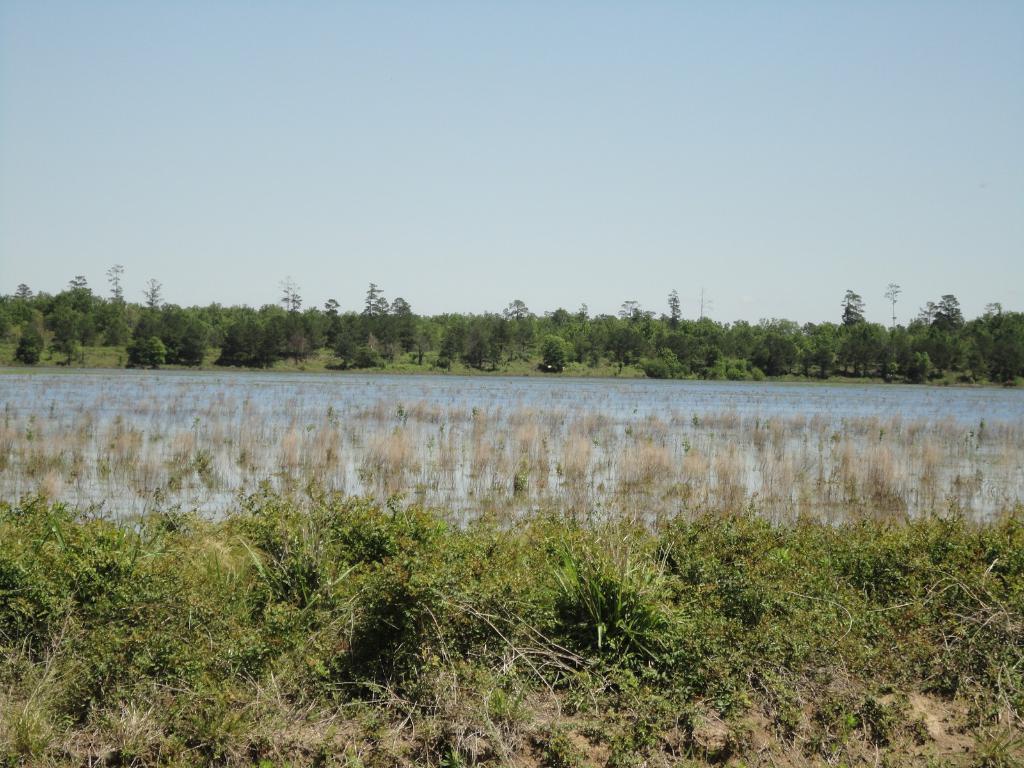Could you give a brief overview of what you see in this image? There are plants, water and trees at the back. 